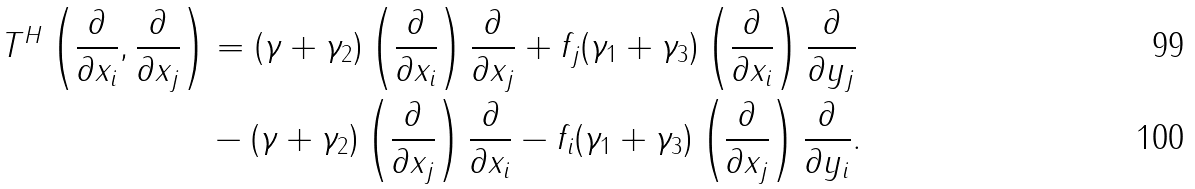Convert formula to latex. <formula><loc_0><loc_0><loc_500><loc_500>T ^ { H } \left ( \frac { \partial } { \partial x _ { i } } , \frac { \partial } { \partial x _ { j } } \right ) & = ( \gamma + \gamma _ { 2 } ) \left ( \frac { \partial } { \partial x _ { i } } \right ) \frac { \partial } { \partial x _ { j } } + f _ { j } ( \gamma _ { 1 } + \gamma _ { 3 } ) \left ( \frac { \partial } { \partial x _ { i } } \right ) \frac { \partial } { \partial y _ { j } } \\ & - ( \gamma + \gamma _ { 2 } ) \left ( \frac { \partial } { \partial x _ { j } } \right ) \frac { \partial } { \partial x _ { i } } - f _ { i } ( \gamma _ { 1 } + \gamma _ { 3 } ) \left ( \frac { \partial } { \partial x _ { j } } \right ) \frac { \partial } { \partial y _ { i } } .</formula> 